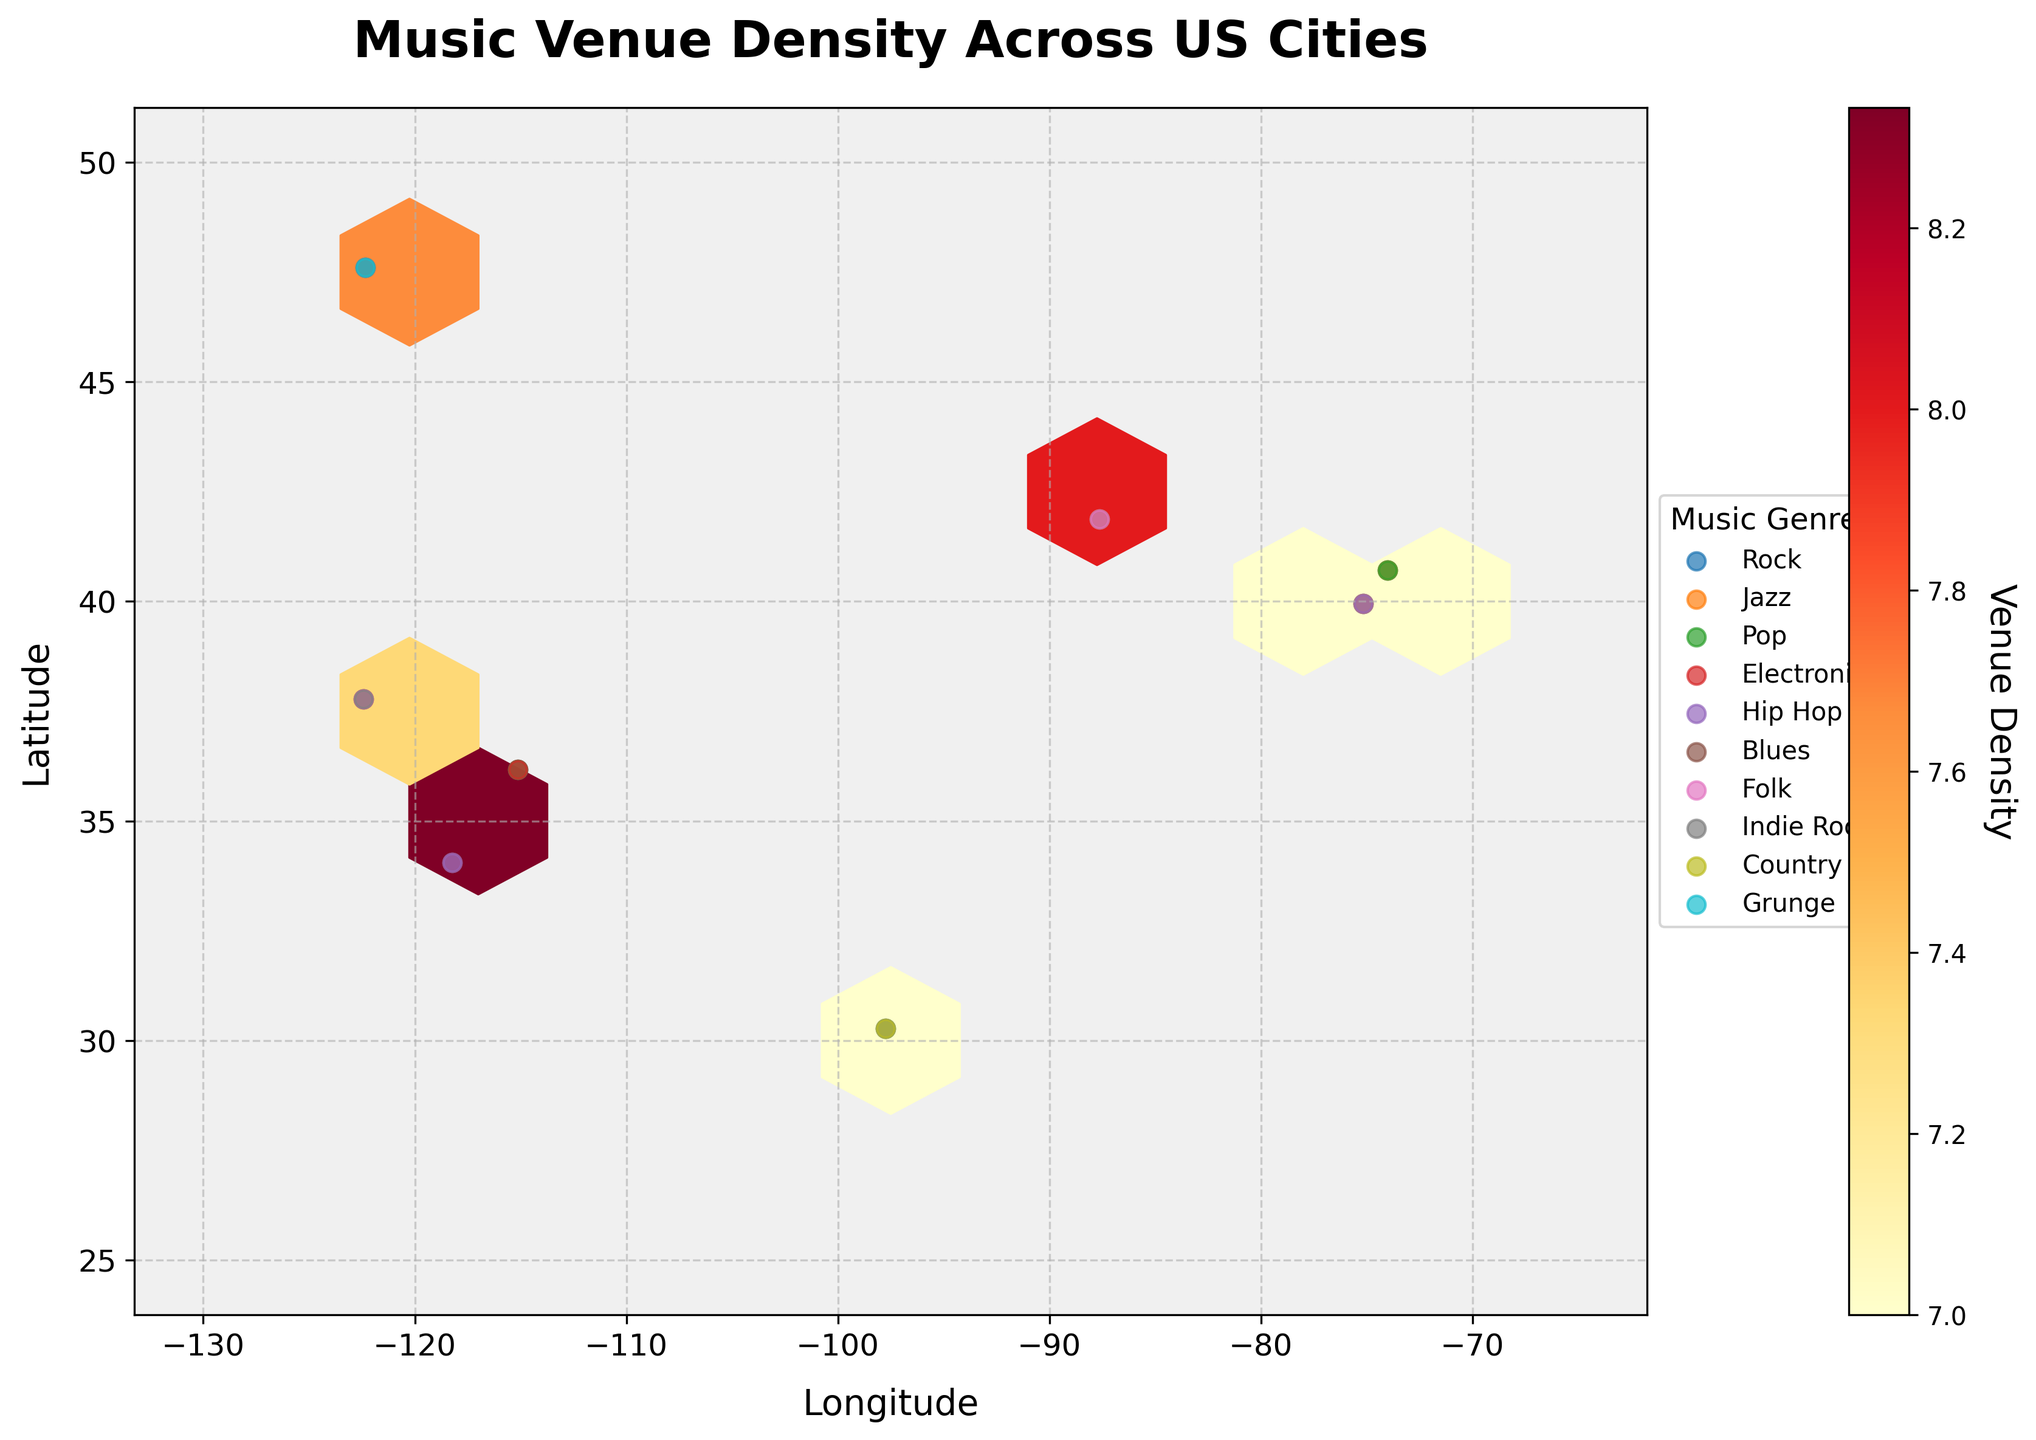What is the title of the hexbin plot? The title is typically displayed at the top of the figure. In this case, the title is "Music Venue Density Across US Cities," which indicates the main focus of the plot.
Answer: Music Venue Density Across US Cities Which genre has the highest venue density in Chicago? To find the genre with the highest venue density, look at the data points for Chicago (latitude around 41.880) and identify the highest value. The Blues genre has a density of 10.
Answer: Blues How are the venue densities represented in the plot? The venue densities are represented using a hexagonal binning method, where the color intensity of each hexagon indicates the density. A color bar suggests that darker colors correspond to higher densities.
Answer: Color intensity of hexagons Which city has the highest concentration of Rock venues? By inspecting the plot, one should look for the city with the darkest hexagonal bins in regions where Rock genre points are present. Los Angeles (latitude around 34.0522) has the highest Rock density of 9.
Answer: Los Angeles What are the latitude and longitude ranges covered by this plot? The latitude and longitude ranges are given by the extent parameters used in the hexbin plot. The plot covers latitude from 25 to 50 and longitude from -130 to -65.
Answer: Latitude: 25 to 50, Longitude: -130 to -65 How does the density of Electronic music venues compare between Los Angeles and Seattle? Look at the hexagonal bins and corresponding scatter points for Electronic venues in both cities. Los Angeles has a density of 8, while Seattle has a density of 6. Therefore, Los Angeles has a higher density of Electronic music venues.
Answer: Los Angeles has higher density Which music genre is denser in New York City, Jazz or Pop? By examining the points within the region for New York City (latitude around 40.7128), compare the densities for Jazz and Pop. Jazz has a density of 6, while Pop has a density of 7. So, Pop is denser.
Answer: Pop Is there a city where Indie Rock and Folk venues have the same density? Compare the densities of Indie Rock and Folk points within each city. In San Francisco (latitude around 37.7749), both Indie Rock and Folk have a density of 6.
Answer: San Francisco What can you infer about the venue density of Grunge music in Seattle? By looking at the scatter plot around Seattle (latitude around 47.6062), the plot shows that Grunge music has a high density of 9. This suggests a strong presence of Grunge venues in Seattle.
Answer: High density (9) 